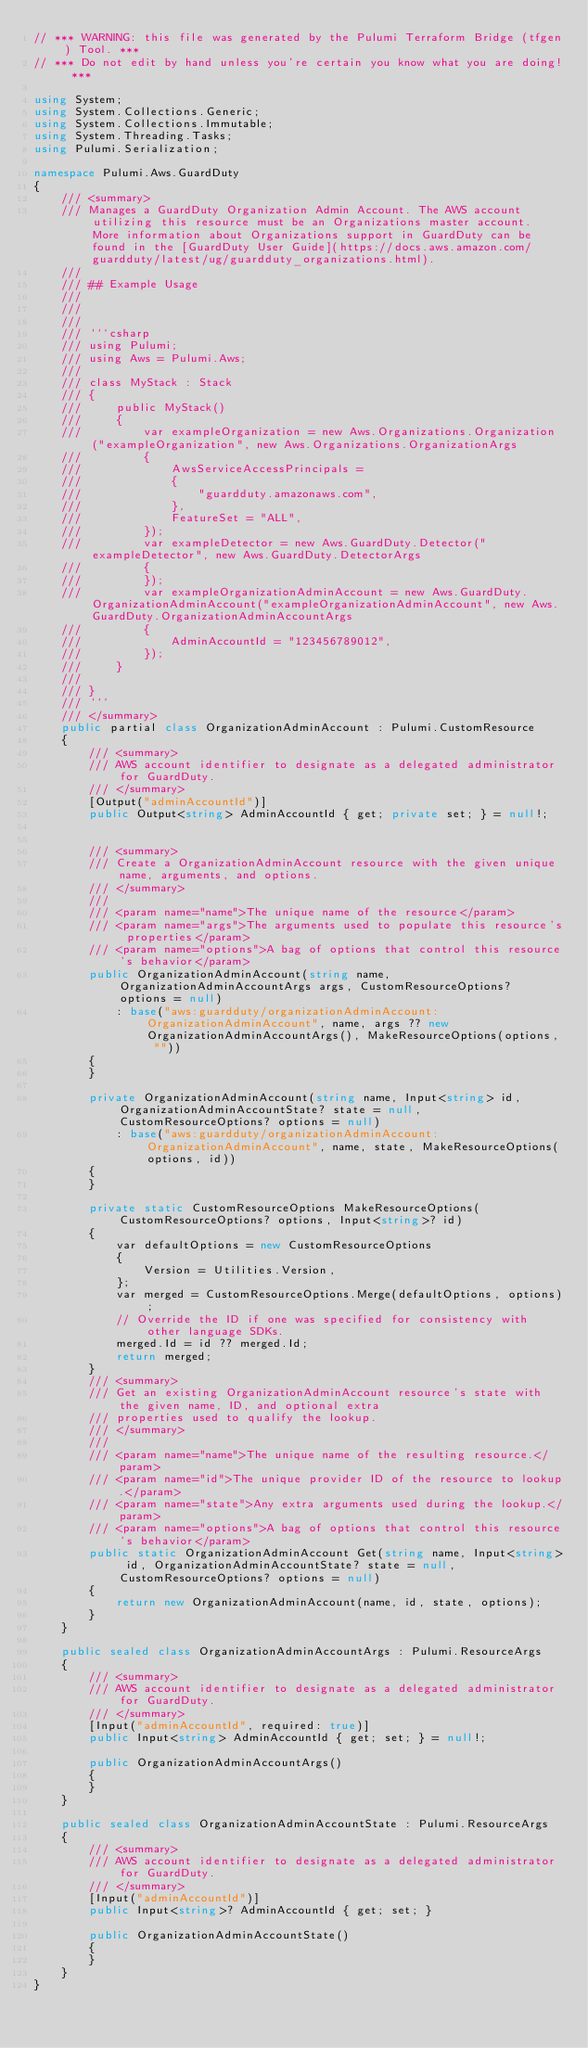Convert code to text. <code><loc_0><loc_0><loc_500><loc_500><_C#_>// *** WARNING: this file was generated by the Pulumi Terraform Bridge (tfgen) Tool. ***
// *** Do not edit by hand unless you're certain you know what you are doing! ***

using System;
using System.Collections.Generic;
using System.Collections.Immutable;
using System.Threading.Tasks;
using Pulumi.Serialization;

namespace Pulumi.Aws.GuardDuty
{
    /// <summary>
    /// Manages a GuardDuty Organization Admin Account. The AWS account utilizing this resource must be an Organizations master account. More information about Organizations support in GuardDuty can be found in the [GuardDuty User Guide](https://docs.aws.amazon.com/guardduty/latest/ug/guardduty_organizations.html).
    /// 
    /// ## Example Usage
    /// 
    /// 
    /// 
    /// ```csharp
    /// using Pulumi;
    /// using Aws = Pulumi.Aws;
    /// 
    /// class MyStack : Stack
    /// {
    ///     public MyStack()
    ///     {
    ///         var exampleOrganization = new Aws.Organizations.Organization("exampleOrganization", new Aws.Organizations.OrganizationArgs
    ///         {
    ///             AwsServiceAccessPrincipals = 
    ///             {
    ///                 "guardduty.amazonaws.com",
    ///             },
    ///             FeatureSet = "ALL",
    ///         });
    ///         var exampleDetector = new Aws.GuardDuty.Detector("exampleDetector", new Aws.GuardDuty.DetectorArgs
    ///         {
    ///         });
    ///         var exampleOrganizationAdminAccount = new Aws.GuardDuty.OrganizationAdminAccount("exampleOrganizationAdminAccount", new Aws.GuardDuty.OrganizationAdminAccountArgs
    ///         {
    ///             AdminAccountId = "123456789012",
    ///         });
    ///     }
    /// 
    /// }
    /// ```
    /// </summary>
    public partial class OrganizationAdminAccount : Pulumi.CustomResource
    {
        /// <summary>
        /// AWS account identifier to designate as a delegated administrator for GuardDuty.
        /// </summary>
        [Output("adminAccountId")]
        public Output<string> AdminAccountId { get; private set; } = null!;


        /// <summary>
        /// Create a OrganizationAdminAccount resource with the given unique name, arguments, and options.
        /// </summary>
        ///
        /// <param name="name">The unique name of the resource</param>
        /// <param name="args">The arguments used to populate this resource's properties</param>
        /// <param name="options">A bag of options that control this resource's behavior</param>
        public OrganizationAdminAccount(string name, OrganizationAdminAccountArgs args, CustomResourceOptions? options = null)
            : base("aws:guardduty/organizationAdminAccount:OrganizationAdminAccount", name, args ?? new OrganizationAdminAccountArgs(), MakeResourceOptions(options, ""))
        {
        }

        private OrganizationAdminAccount(string name, Input<string> id, OrganizationAdminAccountState? state = null, CustomResourceOptions? options = null)
            : base("aws:guardduty/organizationAdminAccount:OrganizationAdminAccount", name, state, MakeResourceOptions(options, id))
        {
        }

        private static CustomResourceOptions MakeResourceOptions(CustomResourceOptions? options, Input<string>? id)
        {
            var defaultOptions = new CustomResourceOptions
            {
                Version = Utilities.Version,
            };
            var merged = CustomResourceOptions.Merge(defaultOptions, options);
            // Override the ID if one was specified for consistency with other language SDKs.
            merged.Id = id ?? merged.Id;
            return merged;
        }
        /// <summary>
        /// Get an existing OrganizationAdminAccount resource's state with the given name, ID, and optional extra
        /// properties used to qualify the lookup.
        /// </summary>
        ///
        /// <param name="name">The unique name of the resulting resource.</param>
        /// <param name="id">The unique provider ID of the resource to lookup.</param>
        /// <param name="state">Any extra arguments used during the lookup.</param>
        /// <param name="options">A bag of options that control this resource's behavior</param>
        public static OrganizationAdminAccount Get(string name, Input<string> id, OrganizationAdminAccountState? state = null, CustomResourceOptions? options = null)
        {
            return new OrganizationAdminAccount(name, id, state, options);
        }
    }

    public sealed class OrganizationAdminAccountArgs : Pulumi.ResourceArgs
    {
        /// <summary>
        /// AWS account identifier to designate as a delegated administrator for GuardDuty.
        /// </summary>
        [Input("adminAccountId", required: true)]
        public Input<string> AdminAccountId { get; set; } = null!;

        public OrganizationAdminAccountArgs()
        {
        }
    }

    public sealed class OrganizationAdminAccountState : Pulumi.ResourceArgs
    {
        /// <summary>
        /// AWS account identifier to designate as a delegated administrator for GuardDuty.
        /// </summary>
        [Input("adminAccountId")]
        public Input<string>? AdminAccountId { get; set; }

        public OrganizationAdminAccountState()
        {
        }
    }
}
</code> 